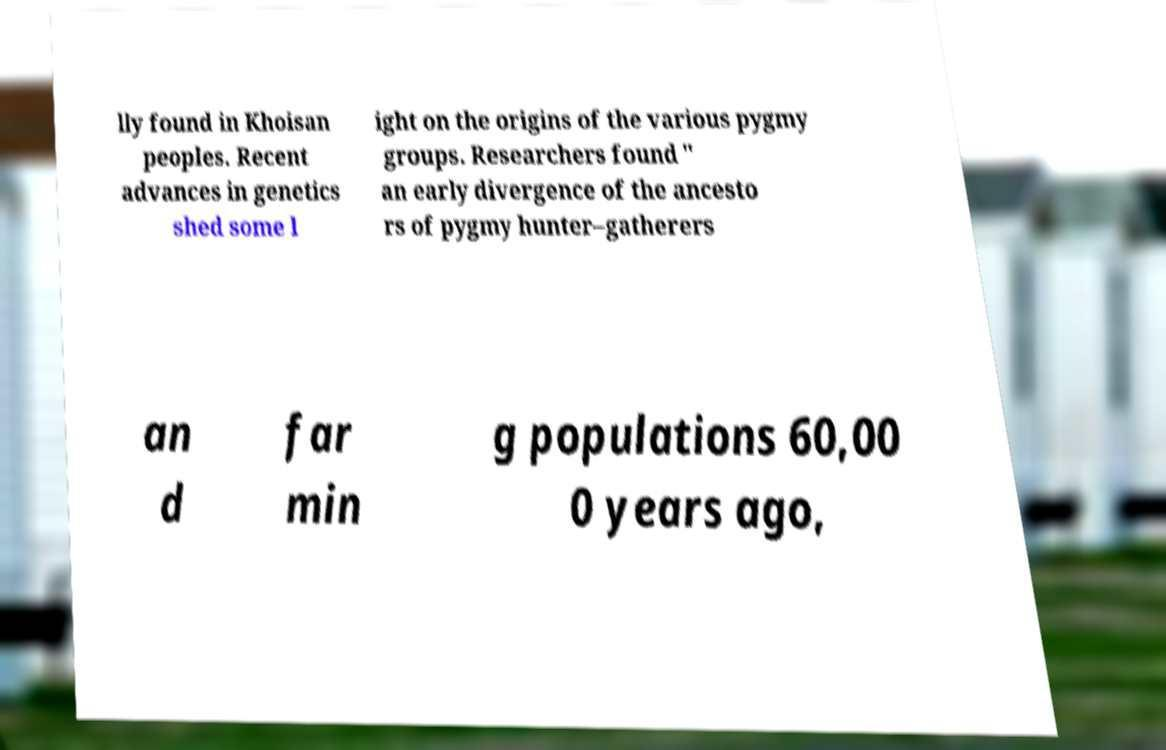Could you assist in decoding the text presented in this image and type it out clearly? lly found in Khoisan peoples. Recent advances in genetics shed some l ight on the origins of the various pygmy groups. Researchers found " an early divergence of the ancesto rs of pygmy hunter–gatherers an d far min g populations 60,00 0 years ago, 